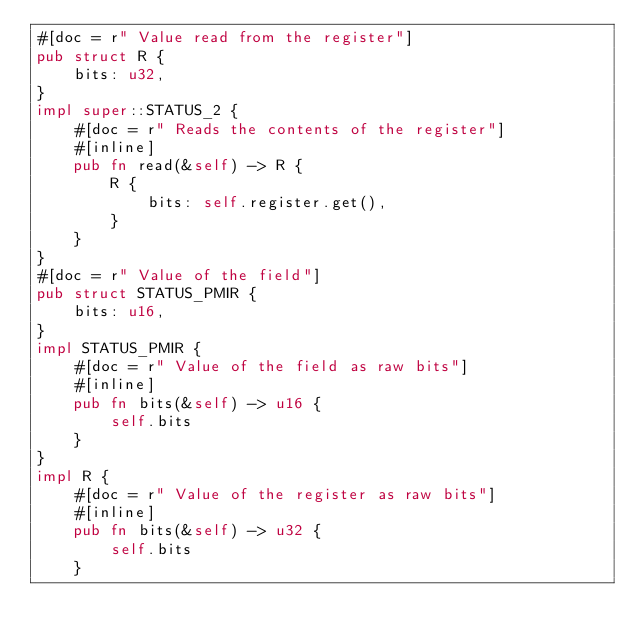<code> <loc_0><loc_0><loc_500><loc_500><_Rust_>#[doc = r" Value read from the register"]
pub struct R {
    bits: u32,
}
impl super::STATUS_2 {
    #[doc = r" Reads the contents of the register"]
    #[inline]
    pub fn read(&self) -> R {
        R {
            bits: self.register.get(),
        }
    }
}
#[doc = r" Value of the field"]
pub struct STATUS_PMIR {
    bits: u16,
}
impl STATUS_PMIR {
    #[doc = r" Value of the field as raw bits"]
    #[inline]
    pub fn bits(&self) -> u16 {
        self.bits
    }
}
impl R {
    #[doc = r" Value of the register as raw bits"]
    #[inline]
    pub fn bits(&self) -> u32 {
        self.bits
    }</code> 